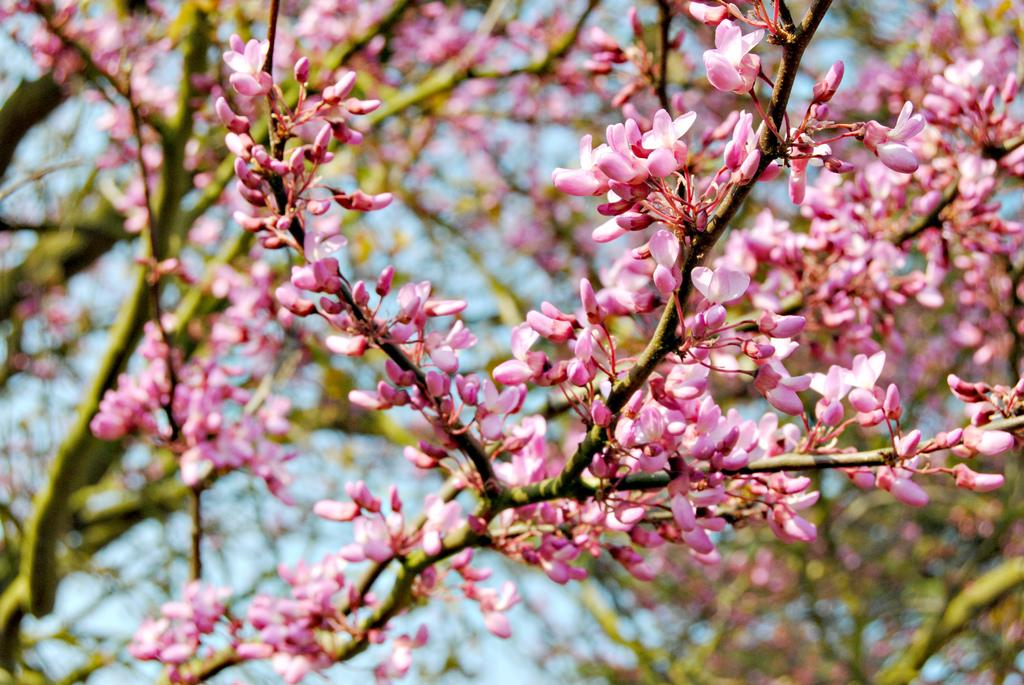What type of plant life is present in the image? There are flowers, buds, and branches in the image. Can you describe the stage of growth for the plant life in the image? The buds in the image suggest that some of the flowers are still in the process of blooming. What is visible in the background of the image? The sky is visible in the background of the image. What type of sack can be seen holding the beef in the image? There is no sack or beef present in the image; it features flowers, buds, and branches. What specific detail about the flowers can be observed in the image? The provided facts do not mention any specific details about the flowers, so we cannot answer this question definitively. 